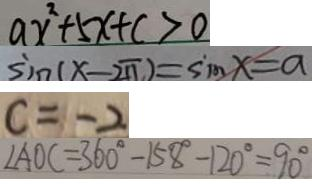Convert formula to latex. <formula><loc_0><loc_0><loc_500><loc_500>a x ^ { 2 } + 5 x + c > 0 
 \sin ( x - 2 \pi ) = \sin x = a 
 c = - 2 
 \angle A O C = 3 6 0 ^ { \circ } - 1 5 8 ^ { \circ } - 1 2 0 ^ { \circ } = 9 0 ^ { \circ }</formula> 